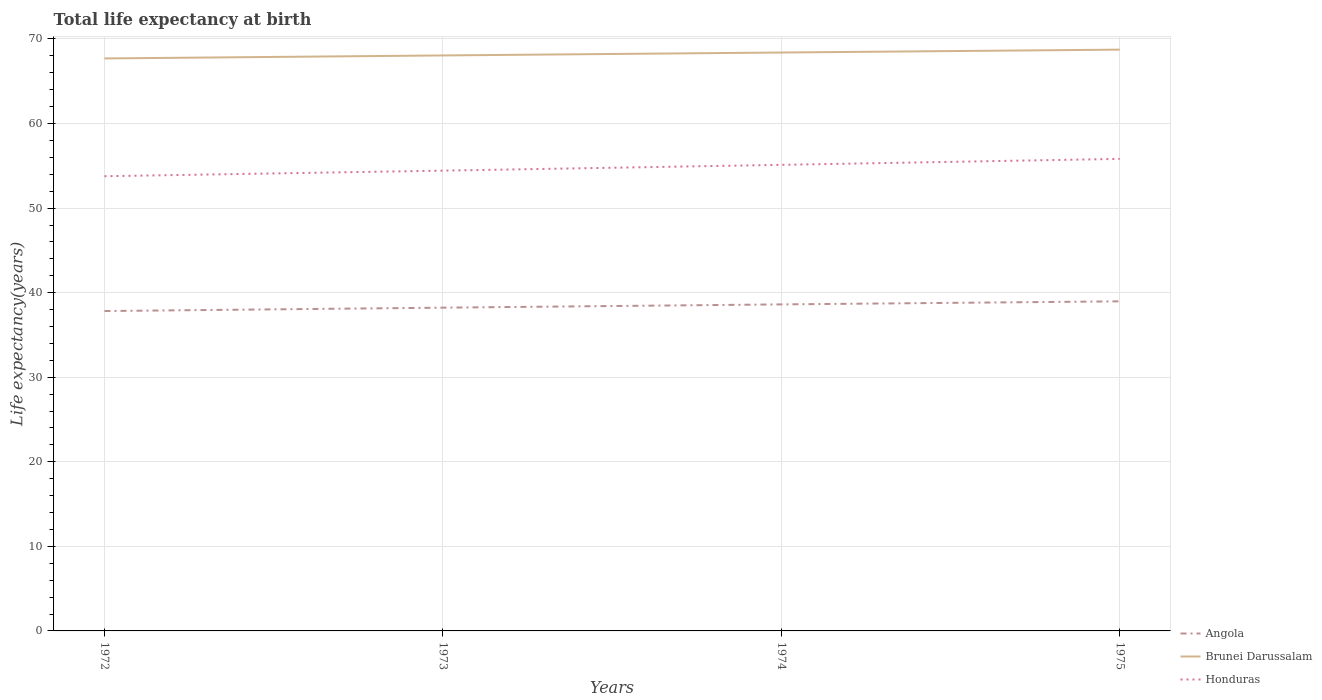Does the line corresponding to Angola intersect with the line corresponding to Honduras?
Your response must be concise. No. Is the number of lines equal to the number of legend labels?
Offer a very short reply. Yes. Across all years, what is the maximum life expectancy at birth in in Brunei Darussalam?
Offer a terse response. 67.7. In which year was the life expectancy at birth in in Angola maximum?
Your answer should be compact. 1972. What is the total life expectancy at birth in in Honduras in the graph?
Keep it short and to the point. -1.34. What is the difference between the highest and the second highest life expectancy at birth in in Honduras?
Provide a short and direct response. 2.05. What is the difference between the highest and the lowest life expectancy at birth in in Brunei Darussalam?
Offer a terse response. 2. Is the life expectancy at birth in in Honduras strictly greater than the life expectancy at birth in in Brunei Darussalam over the years?
Offer a terse response. Yes. Does the graph contain any zero values?
Keep it short and to the point. No. Where does the legend appear in the graph?
Your answer should be very brief. Bottom right. What is the title of the graph?
Offer a terse response. Total life expectancy at birth. Does "Maldives" appear as one of the legend labels in the graph?
Provide a short and direct response. No. What is the label or title of the Y-axis?
Give a very brief answer. Life expectancy(years). What is the Life expectancy(years) in Angola in 1972?
Provide a succinct answer. 37.83. What is the Life expectancy(years) of Brunei Darussalam in 1972?
Offer a terse response. 67.7. What is the Life expectancy(years) in Honduras in 1972?
Ensure brevity in your answer.  53.77. What is the Life expectancy(years) in Angola in 1973?
Your answer should be very brief. 38.23. What is the Life expectancy(years) of Brunei Darussalam in 1973?
Your answer should be compact. 68.05. What is the Life expectancy(years) in Honduras in 1973?
Give a very brief answer. 54.43. What is the Life expectancy(years) of Angola in 1974?
Your answer should be very brief. 38.61. What is the Life expectancy(years) of Brunei Darussalam in 1974?
Your answer should be compact. 68.4. What is the Life expectancy(years) in Honduras in 1974?
Provide a succinct answer. 55.12. What is the Life expectancy(years) in Angola in 1975?
Provide a short and direct response. 38.98. What is the Life expectancy(years) in Brunei Darussalam in 1975?
Your answer should be very brief. 68.74. What is the Life expectancy(years) in Honduras in 1975?
Provide a succinct answer. 55.82. Across all years, what is the maximum Life expectancy(years) of Angola?
Make the answer very short. 38.98. Across all years, what is the maximum Life expectancy(years) of Brunei Darussalam?
Offer a very short reply. 68.74. Across all years, what is the maximum Life expectancy(years) in Honduras?
Your response must be concise. 55.82. Across all years, what is the minimum Life expectancy(years) in Angola?
Offer a very short reply. 37.83. Across all years, what is the minimum Life expectancy(years) of Brunei Darussalam?
Provide a succinct answer. 67.7. Across all years, what is the minimum Life expectancy(years) in Honduras?
Offer a terse response. 53.77. What is the total Life expectancy(years) in Angola in the graph?
Keep it short and to the point. 153.64. What is the total Life expectancy(years) in Brunei Darussalam in the graph?
Your answer should be very brief. 272.89. What is the total Life expectancy(years) in Honduras in the graph?
Offer a very short reply. 219.14. What is the difference between the Life expectancy(years) in Angola in 1972 and that in 1973?
Keep it short and to the point. -0.4. What is the difference between the Life expectancy(years) in Brunei Darussalam in 1972 and that in 1973?
Your answer should be very brief. -0.35. What is the difference between the Life expectancy(years) in Honduras in 1972 and that in 1973?
Give a very brief answer. -0.66. What is the difference between the Life expectancy(years) of Angola in 1972 and that in 1974?
Offer a very short reply. -0.79. What is the difference between the Life expectancy(years) of Brunei Darussalam in 1972 and that in 1974?
Give a very brief answer. -0.7. What is the difference between the Life expectancy(years) in Honduras in 1972 and that in 1974?
Your answer should be very brief. -1.34. What is the difference between the Life expectancy(years) of Angola in 1972 and that in 1975?
Ensure brevity in your answer.  -1.15. What is the difference between the Life expectancy(years) of Brunei Darussalam in 1972 and that in 1975?
Make the answer very short. -1.04. What is the difference between the Life expectancy(years) in Honduras in 1972 and that in 1975?
Give a very brief answer. -2.05. What is the difference between the Life expectancy(years) in Angola in 1973 and that in 1974?
Provide a succinct answer. -0.39. What is the difference between the Life expectancy(years) of Brunei Darussalam in 1973 and that in 1974?
Keep it short and to the point. -0.35. What is the difference between the Life expectancy(years) of Honduras in 1973 and that in 1974?
Your answer should be very brief. -0.68. What is the difference between the Life expectancy(years) of Angola in 1973 and that in 1975?
Make the answer very short. -0.75. What is the difference between the Life expectancy(years) in Brunei Darussalam in 1973 and that in 1975?
Your answer should be compact. -0.69. What is the difference between the Life expectancy(years) in Honduras in 1973 and that in 1975?
Give a very brief answer. -1.39. What is the difference between the Life expectancy(years) in Angola in 1974 and that in 1975?
Provide a succinct answer. -0.36. What is the difference between the Life expectancy(years) in Brunei Darussalam in 1974 and that in 1975?
Your answer should be very brief. -0.34. What is the difference between the Life expectancy(years) in Honduras in 1974 and that in 1975?
Your answer should be very brief. -0.71. What is the difference between the Life expectancy(years) of Angola in 1972 and the Life expectancy(years) of Brunei Darussalam in 1973?
Provide a succinct answer. -30.23. What is the difference between the Life expectancy(years) in Angola in 1972 and the Life expectancy(years) in Honduras in 1973?
Your answer should be very brief. -16.6. What is the difference between the Life expectancy(years) in Brunei Darussalam in 1972 and the Life expectancy(years) in Honduras in 1973?
Your answer should be compact. 13.27. What is the difference between the Life expectancy(years) in Angola in 1972 and the Life expectancy(years) in Brunei Darussalam in 1974?
Ensure brevity in your answer.  -30.57. What is the difference between the Life expectancy(years) in Angola in 1972 and the Life expectancy(years) in Honduras in 1974?
Make the answer very short. -17.29. What is the difference between the Life expectancy(years) in Brunei Darussalam in 1972 and the Life expectancy(years) in Honduras in 1974?
Your answer should be compact. 12.58. What is the difference between the Life expectancy(years) in Angola in 1972 and the Life expectancy(years) in Brunei Darussalam in 1975?
Keep it short and to the point. -30.91. What is the difference between the Life expectancy(years) of Angola in 1972 and the Life expectancy(years) of Honduras in 1975?
Give a very brief answer. -18. What is the difference between the Life expectancy(years) of Brunei Darussalam in 1972 and the Life expectancy(years) of Honduras in 1975?
Keep it short and to the point. 11.88. What is the difference between the Life expectancy(years) of Angola in 1973 and the Life expectancy(years) of Brunei Darussalam in 1974?
Your response must be concise. -30.17. What is the difference between the Life expectancy(years) in Angola in 1973 and the Life expectancy(years) in Honduras in 1974?
Keep it short and to the point. -16.89. What is the difference between the Life expectancy(years) in Brunei Darussalam in 1973 and the Life expectancy(years) in Honduras in 1974?
Provide a short and direct response. 12.94. What is the difference between the Life expectancy(years) of Angola in 1973 and the Life expectancy(years) of Brunei Darussalam in 1975?
Your answer should be compact. -30.51. What is the difference between the Life expectancy(years) of Angola in 1973 and the Life expectancy(years) of Honduras in 1975?
Provide a succinct answer. -17.6. What is the difference between the Life expectancy(years) of Brunei Darussalam in 1973 and the Life expectancy(years) of Honduras in 1975?
Provide a short and direct response. 12.23. What is the difference between the Life expectancy(years) in Angola in 1974 and the Life expectancy(years) in Brunei Darussalam in 1975?
Your response must be concise. -30.13. What is the difference between the Life expectancy(years) of Angola in 1974 and the Life expectancy(years) of Honduras in 1975?
Give a very brief answer. -17.21. What is the difference between the Life expectancy(years) in Brunei Darussalam in 1974 and the Life expectancy(years) in Honduras in 1975?
Provide a succinct answer. 12.58. What is the average Life expectancy(years) in Angola per year?
Your answer should be very brief. 38.41. What is the average Life expectancy(years) of Brunei Darussalam per year?
Your answer should be very brief. 68.22. What is the average Life expectancy(years) in Honduras per year?
Keep it short and to the point. 54.78. In the year 1972, what is the difference between the Life expectancy(years) in Angola and Life expectancy(years) in Brunei Darussalam?
Keep it short and to the point. -29.87. In the year 1972, what is the difference between the Life expectancy(years) of Angola and Life expectancy(years) of Honduras?
Keep it short and to the point. -15.94. In the year 1972, what is the difference between the Life expectancy(years) of Brunei Darussalam and Life expectancy(years) of Honduras?
Offer a very short reply. 13.93. In the year 1973, what is the difference between the Life expectancy(years) of Angola and Life expectancy(years) of Brunei Darussalam?
Your response must be concise. -29.83. In the year 1973, what is the difference between the Life expectancy(years) of Angola and Life expectancy(years) of Honduras?
Provide a succinct answer. -16.2. In the year 1973, what is the difference between the Life expectancy(years) in Brunei Darussalam and Life expectancy(years) in Honduras?
Your answer should be very brief. 13.62. In the year 1974, what is the difference between the Life expectancy(years) in Angola and Life expectancy(years) in Brunei Darussalam?
Offer a very short reply. -29.79. In the year 1974, what is the difference between the Life expectancy(years) of Angola and Life expectancy(years) of Honduras?
Offer a terse response. -16.5. In the year 1974, what is the difference between the Life expectancy(years) of Brunei Darussalam and Life expectancy(years) of Honduras?
Provide a succinct answer. 13.29. In the year 1975, what is the difference between the Life expectancy(years) of Angola and Life expectancy(years) of Brunei Darussalam?
Your answer should be compact. -29.76. In the year 1975, what is the difference between the Life expectancy(years) in Angola and Life expectancy(years) in Honduras?
Provide a succinct answer. -16.85. In the year 1975, what is the difference between the Life expectancy(years) of Brunei Darussalam and Life expectancy(years) of Honduras?
Give a very brief answer. 12.92. What is the ratio of the Life expectancy(years) in Honduras in 1972 to that in 1973?
Provide a short and direct response. 0.99. What is the ratio of the Life expectancy(years) of Angola in 1972 to that in 1974?
Your answer should be very brief. 0.98. What is the ratio of the Life expectancy(years) in Honduras in 1972 to that in 1974?
Give a very brief answer. 0.98. What is the ratio of the Life expectancy(years) of Angola in 1972 to that in 1975?
Ensure brevity in your answer.  0.97. What is the ratio of the Life expectancy(years) in Brunei Darussalam in 1972 to that in 1975?
Your response must be concise. 0.98. What is the ratio of the Life expectancy(years) of Honduras in 1972 to that in 1975?
Your answer should be very brief. 0.96. What is the ratio of the Life expectancy(years) of Brunei Darussalam in 1973 to that in 1974?
Provide a short and direct response. 0.99. What is the ratio of the Life expectancy(years) in Honduras in 1973 to that in 1974?
Provide a succinct answer. 0.99. What is the ratio of the Life expectancy(years) in Angola in 1973 to that in 1975?
Your response must be concise. 0.98. What is the ratio of the Life expectancy(years) of Brunei Darussalam in 1973 to that in 1975?
Your answer should be compact. 0.99. What is the ratio of the Life expectancy(years) in Honduras in 1973 to that in 1975?
Your answer should be compact. 0.98. What is the ratio of the Life expectancy(years) in Angola in 1974 to that in 1975?
Offer a very short reply. 0.99. What is the ratio of the Life expectancy(years) of Honduras in 1974 to that in 1975?
Your response must be concise. 0.99. What is the difference between the highest and the second highest Life expectancy(years) of Angola?
Offer a terse response. 0.36. What is the difference between the highest and the second highest Life expectancy(years) in Brunei Darussalam?
Offer a very short reply. 0.34. What is the difference between the highest and the second highest Life expectancy(years) of Honduras?
Keep it short and to the point. 0.71. What is the difference between the highest and the lowest Life expectancy(years) in Angola?
Offer a terse response. 1.15. What is the difference between the highest and the lowest Life expectancy(years) of Brunei Darussalam?
Ensure brevity in your answer.  1.04. What is the difference between the highest and the lowest Life expectancy(years) of Honduras?
Your response must be concise. 2.05. 